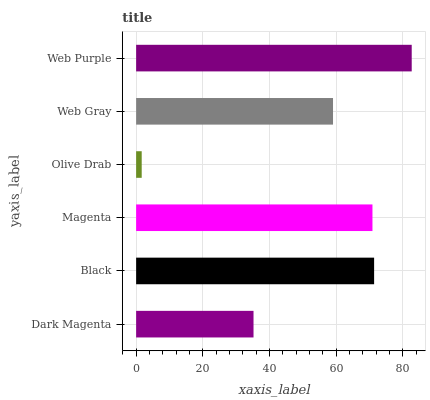Is Olive Drab the minimum?
Answer yes or no. Yes. Is Web Purple the maximum?
Answer yes or no. Yes. Is Black the minimum?
Answer yes or no. No. Is Black the maximum?
Answer yes or no. No. Is Black greater than Dark Magenta?
Answer yes or no. Yes. Is Dark Magenta less than Black?
Answer yes or no. Yes. Is Dark Magenta greater than Black?
Answer yes or no. No. Is Black less than Dark Magenta?
Answer yes or no. No. Is Magenta the high median?
Answer yes or no. Yes. Is Web Gray the low median?
Answer yes or no. Yes. Is Dark Magenta the high median?
Answer yes or no. No. Is Dark Magenta the low median?
Answer yes or no. No. 